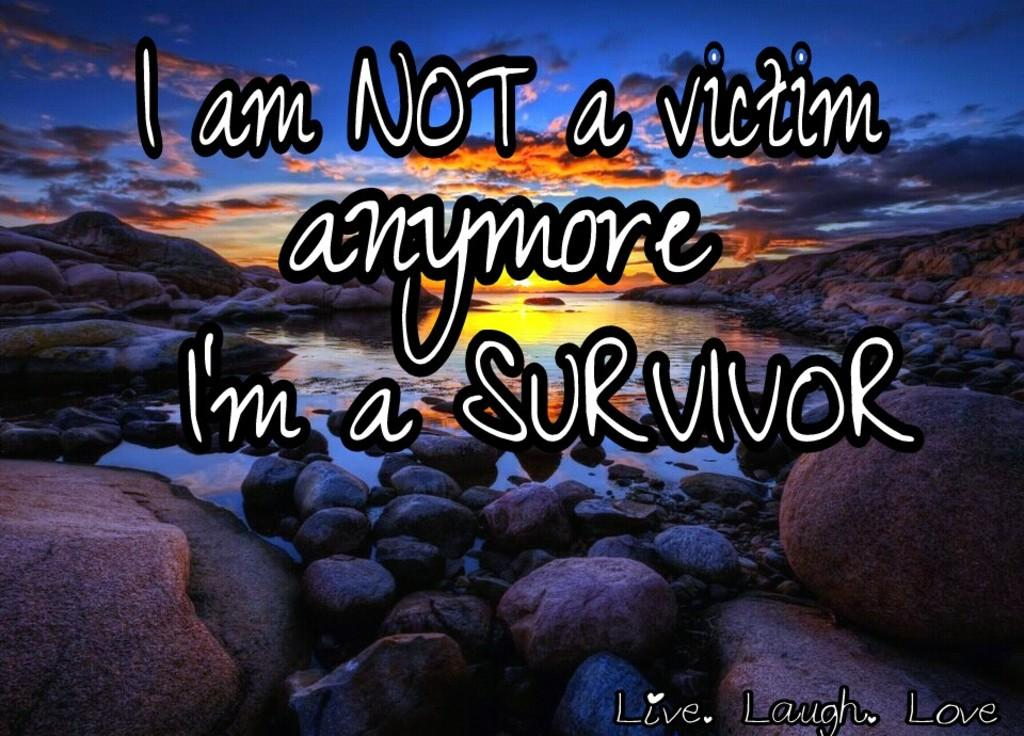<image>
Share a concise interpretation of the image provided. A slogan about being a survivor is shown over a sunset scene. 